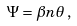Convert formula to latex. <formula><loc_0><loc_0><loc_500><loc_500>\Psi = \beta n \theta \, ,</formula> 